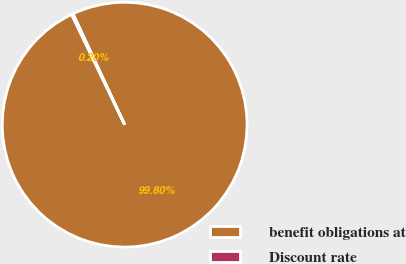<chart> <loc_0><loc_0><loc_500><loc_500><pie_chart><fcel>benefit obligations at<fcel>Discount rate<nl><fcel>99.8%<fcel>0.2%<nl></chart> 